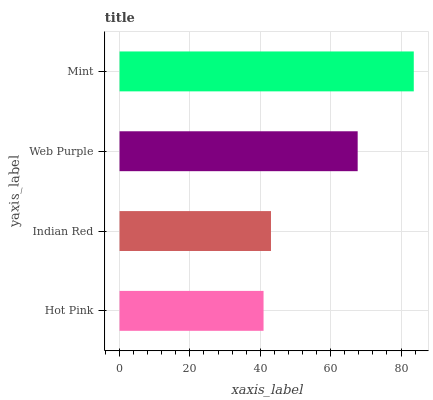Is Hot Pink the minimum?
Answer yes or no. Yes. Is Mint the maximum?
Answer yes or no. Yes. Is Indian Red the minimum?
Answer yes or no. No. Is Indian Red the maximum?
Answer yes or no. No. Is Indian Red greater than Hot Pink?
Answer yes or no. Yes. Is Hot Pink less than Indian Red?
Answer yes or no. Yes. Is Hot Pink greater than Indian Red?
Answer yes or no. No. Is Indian Red less than Hot Pink?
Answer yes or no. No. Is Web Purple the high median?
Answer yes or no. Yes. Is Indian Red the low median?
Answer yes or no. Yes. Is Hot Pink the high median?
Answer yes or no. No. Is Hot Pink the low median?
Answer yes or no. No. 